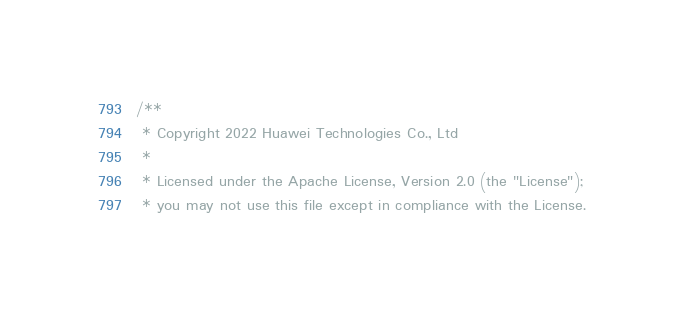<code> <loc_0><loc_0><loc_500><loc_500><_C++_>/**
 * Copyright 2022 Huawei Technologies Co., Ltd
 *
 * Licensed under the Apache License, Version 2.0 (the "License");
 * you may not use this file except in compliance with the License.</code> 